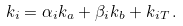<formula> <loc_0><loc_0><loc_500><loc_500>k _ { i } = \alpha _ { i } k _ { a } + \beta _ { i } k _ { b } + k _ { i T } \, .</formula> 